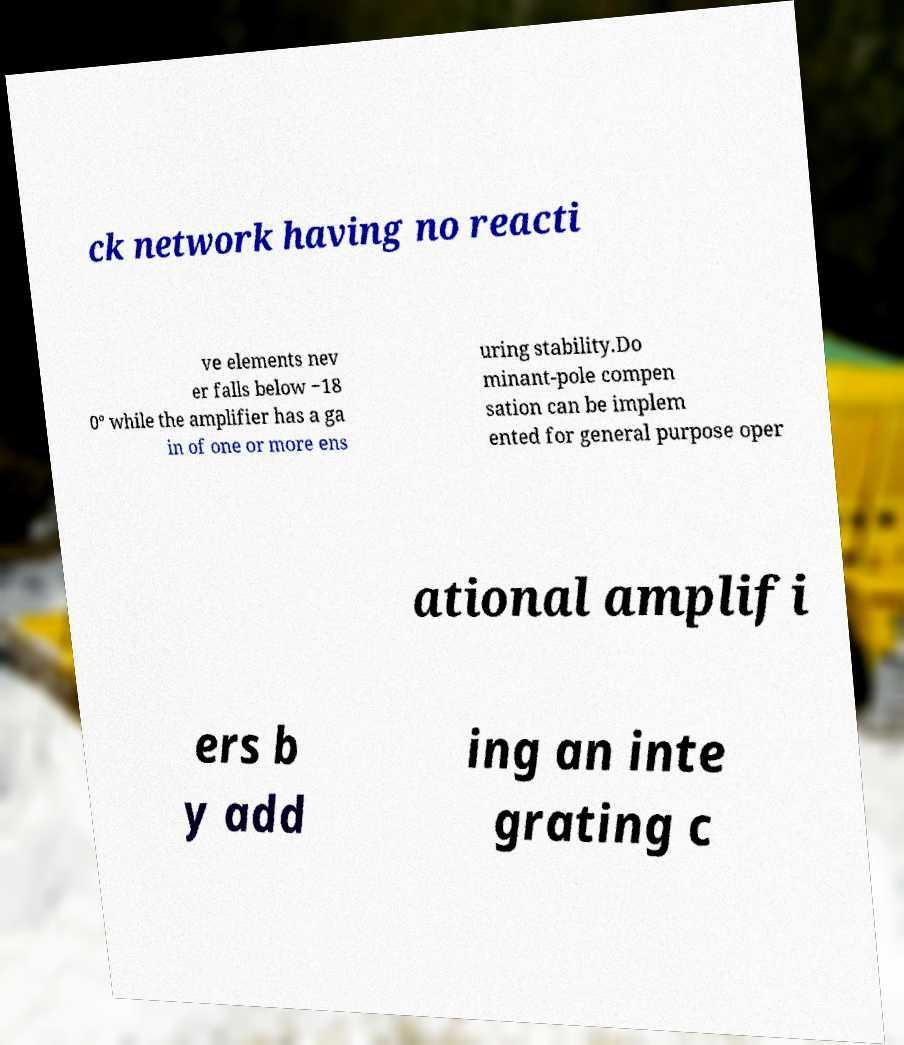Can you accurately transcribe the text from the provided image for me? ck network having no reacti ve elements nev er falls below −18 0° while the amplifier has a ga in of one or more ens uring stability.Do minant-pole compen sation can be implem ented for general purpose oper ational amplifi ers b y add ing an inte grating c 